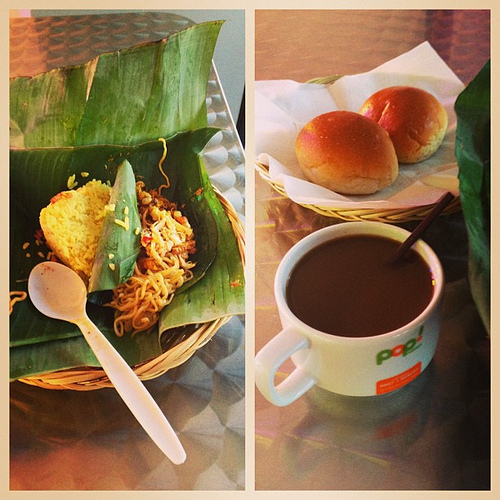What is the spoon in? The white spoon is nestled within a charmingly rustic woven basket that also contains noodles. 